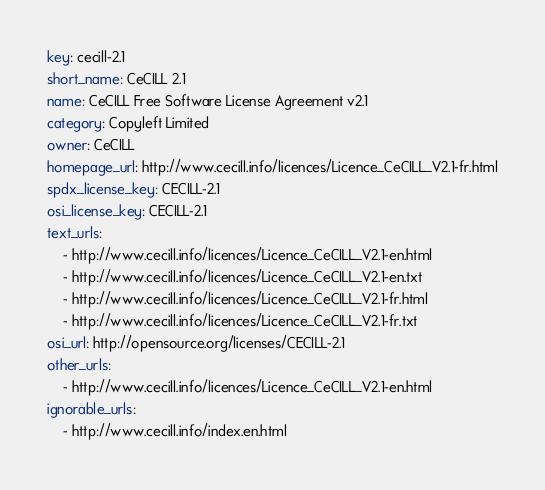Convert code to text. <code><loc_0><loc_0><loc_500><loc_500><_YAML_>key: cecill-2.1
short_name: CeCILL 2.1
name: CeCILL Free Software License Agreement v2.1
category: Copyleft Limited
owner: CeCILL
homepage_url: http://www.cecill.info/licences/Licence_CeCILL_V2.1-fr.html
spdx_license_key: CECILL-2.1
osi_license_key: CECILL-2.1
text_urls:
    - http://www.cecill.info/licences/Licence_CeCILL_V2.1-en.html
    - http://www.cecill.info/licences/Licence_CeCILL_V2.1-en.txt
    - http://www.cecill.info/licences/Licence_CeCILL_V2.1-fr.html
    - http://www.cecill.info/licences/Licence_CeCILL_V2.1-fr.txt
osi_url: http://opensource.org/licenses/CECILL-2.1
other_urls:
    - http://www.cecill.info/licences/Licence_CeCILL_V2.1-en.html
ignorable_urls:
    - http://www.cecill.info/index.en.html
</code> 